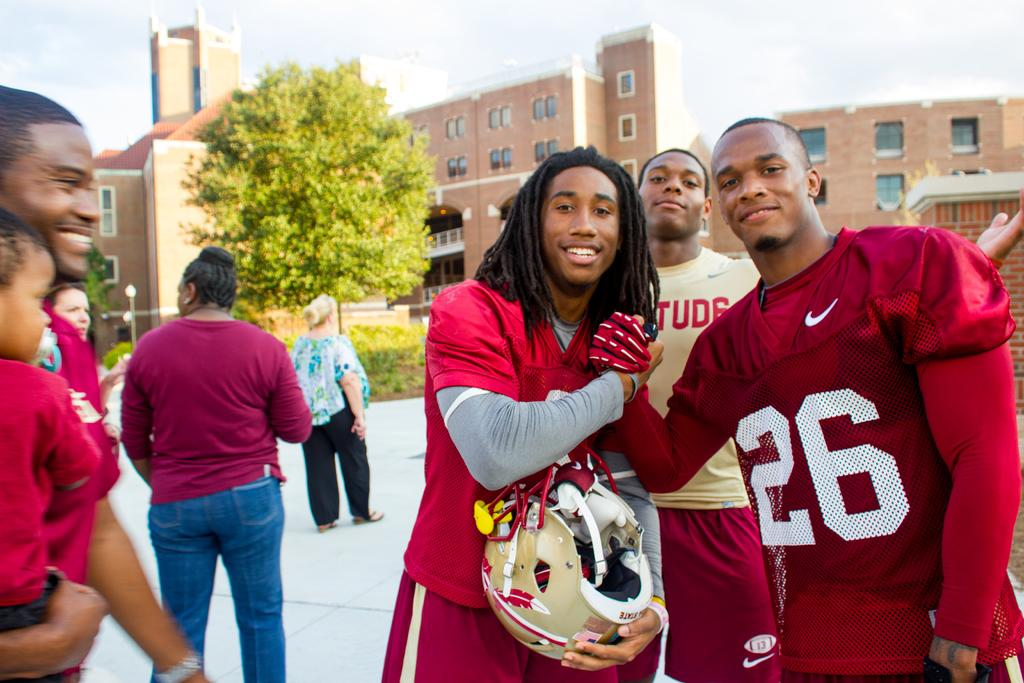<image>
Render a clear and concise summary of the photo. Player 26 grasps hands with another player with long dreadlocks who is holding a gold helmet. 